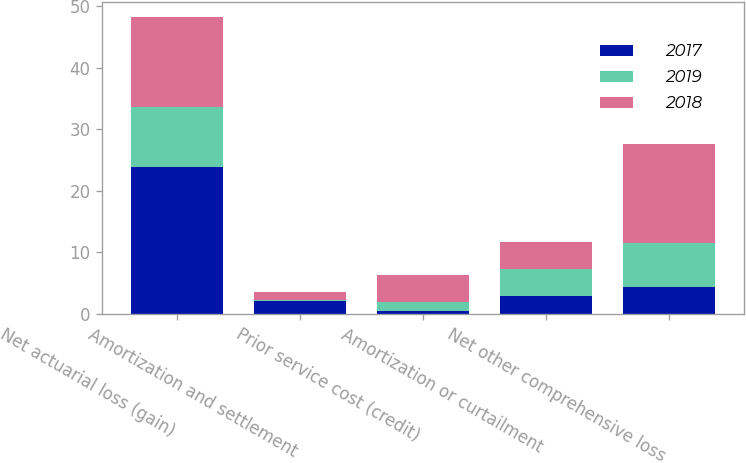<chart> <loc_0><loc_0><loc_500><loc_500><stacked_bar_chart><ecel><fcel>Net actuarial loss (gain)<fcel>Amortization and settlement<fcel>Prior service cost (credit)<fcel>Amortization or curtailment<fcel>Net other comprehensive loss<nl><fcel>2017<fcel>23.9<fcel>2<fcel>0.4<fcel>2.8<fcel>4.4<nl><fcel>2019<fcel>9.7<fcel>0.3<fcel>1.5<fcel>4.4<fcel>7.1<nl><fcel>2018<fcel>14.7<fcel>1.3<fcel>4.4<fcel>4.5<fcel>16.1<nl></chart> 